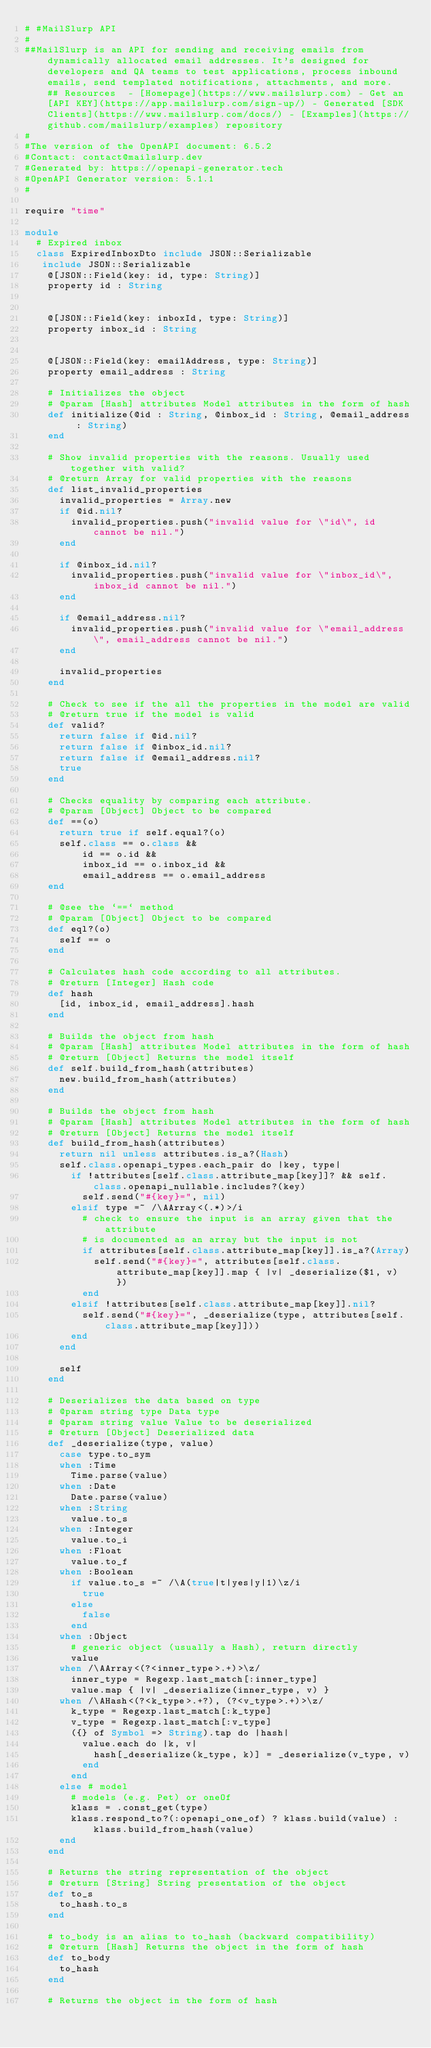Convert code to text. <code><loc_0><loc_0><loc_500><loc_500><_Crystal_># #MailSlurp API
#
##MailSlurp is an API for sending and receiving emails from dynamically allocated email addresses. It's designed for developers and QA teams to test applications, process inbound emails, send templated notifications, attachments, and more.  ## Resources  - [Homepage](https://www.mailslurp.com) - Get an [API KEY](https://app.mailslurp.com/sign-up/) - Generated [SDK Clients](https://www.mailslurp.com/docs/) - [Examples](https://github.com/mailslurp/examples) repository
#
#The version of the OpenAPI document: 6.5.2
#Contact: contact@mailslurp.dev
#Generated by: https://openapi-generator.tech
#OpenAPI Generator version: 5.1.1
#

require "time"

module 
  # Expired inbox
  class ExpiredInboxDto include JSON::Serializable
   include JSON::Serializable 
    @[JSON::Field(key: id, type: String)]
    property id : String


    @[JSON::Field(key: inboxId, type: String)]
    property inbox_id : String


    @[JSON::Field(key: emailAddress, type: String)]
    property email_address : String

    # Initializes the object
    # @param [Hash] attributes Model attributes in the form of hash
    def initialize(@id : String, @inbox_id : String, @email_address : String)
    end

    # Show invalid properties with the reasons. Usually used together with valid?
    # @return Array for valid properties with the reasons
    def list_invalid_properties
      invalid_properties = Array.new
      if @id.nil?
        invalid_properties.push("invalid value for \"id\", id cannot be nil.")
      end

      if @inbox_id.nil?
        invalid_properties.push("invalid value for \"inbox_id\", inbox_id cannot be nil.")
      end

      if @email_address.nil?
        invalid_properties.push("invalid value for \"email_address\", email_address cannot be nil.")
      end

      invalid_properties
    end

    # Check to see if the all the properties in the model are valid
    # @return true if the model is valid
    def valid?
      return false if @id.nil?
      return false if @inbox_id.nil?
      return false if @email_address.nil?
      true
    end

    # Checks equality by comparing each attribute.
    # @param [Object] Object to be compared
    def ==(o)
      return true if self.equal?(o)
      self.class == o.class &&
          id == o.id &&
          inbox_id == o.inbox_id &&
          email_address == o.email_address
    end

    # @see the `==` method
    # @param [Object] Object to be compared
    def eql?(o)
      self == o
    end

    # Calculates hash code according to all attributes.
    # @return [Integer] Hash code
    def hash
      [id, inbox_id, email_address].hash
    end

    # Builds the object from hash
    # @param [Hash] attributes Model attributes in the form of hash
    # @return [Object] Returns the model itself
    def self.build_from_hash(attributes)
      new.build_from_hash(attributes)
    end

    # Builds the object from hash
    # @param [Hash] attributes Model attributes in the form of hash
    # @return [Object] Returns the model itself
    def build_from_hash(attributes)
      return nil unless attributes.is_a?(Hash)
      self.class.openapi_types.each_pair do |key, type|
        if !attributes[self.class.attribute_map[key]]? && self.class.openapi_nullable.includes?(key)
          self.send("#{key}=", nil)
        elsif type =~ /\AArray<(.*)>/i
          # check to ensure the input is an array given that the attribute
          # is documented as an array but the input is not
          if attributes[self.class.attribute_map[key]].is_a?(Array)
            self.send("#{key}=", attributes[self.class.attribute_map[key]].map { |v| _deserialize($1, v) })
          end
        elsif !attributes[self.class.attribute_map[key]].nil?
          self.send("#{key}=", _deserialize(type, attributes[self.class.attribute_map[key]]))
        end
      end

      self
    end

    # Deserializes the data based on type
    # @param string type Data type
    # @param string value Value to be deserialized
    # @return [Object] Deserialized data
    def _deserialize(type, value)
      case type.to_sym
      when :Time
        Time.parse(value)
      when :Date
        Date.parse(value)
      when :String
        value.to_s
      when :Integer
        value.to_i
      when :Float
        value.to_f
      when :Boolean
        if value.to_s =~ /\A(true|t|yes|y|1)\z/i
          true
        else
          false
        end
      when :Object
        # generic object (usually a Hash), return directly
        value
      when /\AArray<(?<inner_type>.+)>\z/
        inner_type = Regexp.last_match[:inner_type]
        value.map { |v| _deserialize(inner_type, v) }
      when /\AHash<(?<k_type>.+?), (?<v_type>.+)>\z/
        k_type = Regexp.last_match[:k_type]
        v_type = Regexp.last_match[:v_type]
        ({} of Symbol => String).tap do |hash|
          value.each do |k, v|
            hash[_deserialize(k_type, k)] = _deserialize(v_type, v)
          end
        end
      else # model
        # models (e.g. Pet) or oneOf
        klass = .const_get(type)
        klass.respond_to?(:openapi_one_of) ? klass.build(value) : klass.build_from_hash(value)
      end
    end

    # Returns the string representation of the object
    # @return [String] String presentation of the object
    def to_s
      to_hash.to_s
    end

    # to_body is an alias to to_hash (backward compatibility)
    # @return [Hash] Returns the object in the form of hash
    def to_body
      to_hash
    end

    # Returns the object in the form of hash</code> 